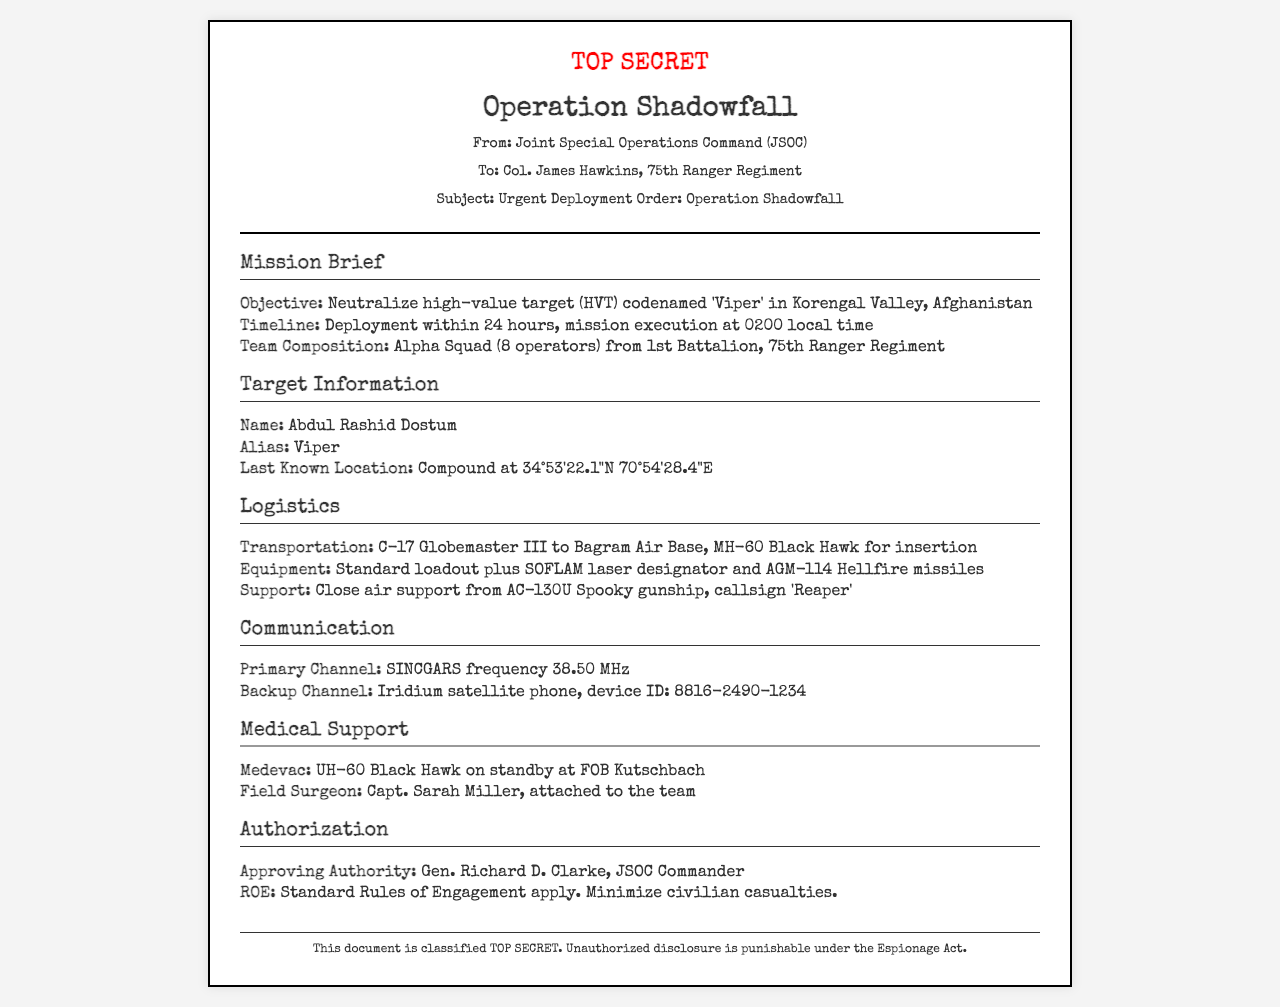What is the name of the target? The target's name is explicitly mentioned in the document, which is Abdul Rashid Dostum.
Answer: Abdul Rashid Dostum What is the alias of the target? The document provides the alias of the target, which is 'Viper'.
Answer: Viper What is the mission execution time? The document specifies that the mission execution is scheduled for 0200 local time.
Answer: 0200 local time How many operators are in Alpha Squad? The document explicitly states that there are 8 operators in Alpha Squad.
Answer: 8 operators What is the primary communication channel mentioned? The document states the primary communication channel as SINCGARS frequency 38.50 MHz.
Answer: SINCGARS frequency 38.50 MHz Who is the field surgeon attached to the team? The document identifies the field surgeon assigned to the team as Capt. Sarah Miller.
Answer: Capt. Sarah Miller What is the name of the approving authority? The approving authority is mentioned in the document as Gen. Richard D. Clarke.
Answer: Gen. Richard D. Clarke What is the mean of transportation to Bagram Air Base? The transportation method detailed in the document for getting to Bagram Air Base is C-17 Globemaster III.
Answer: C-17 Globemaster III What kind of support is provided by AC-130U? The document states that close air support is provided by the AC-130U Spooky gunship.
Answer: Close air support What are the Rules of Engagement? The document states that the Rules of Engagement are standard, with an emphasis on minimizing civilian casualties.
Answer: Standard Rules of Engagement apply. Minimize civilian casualties 